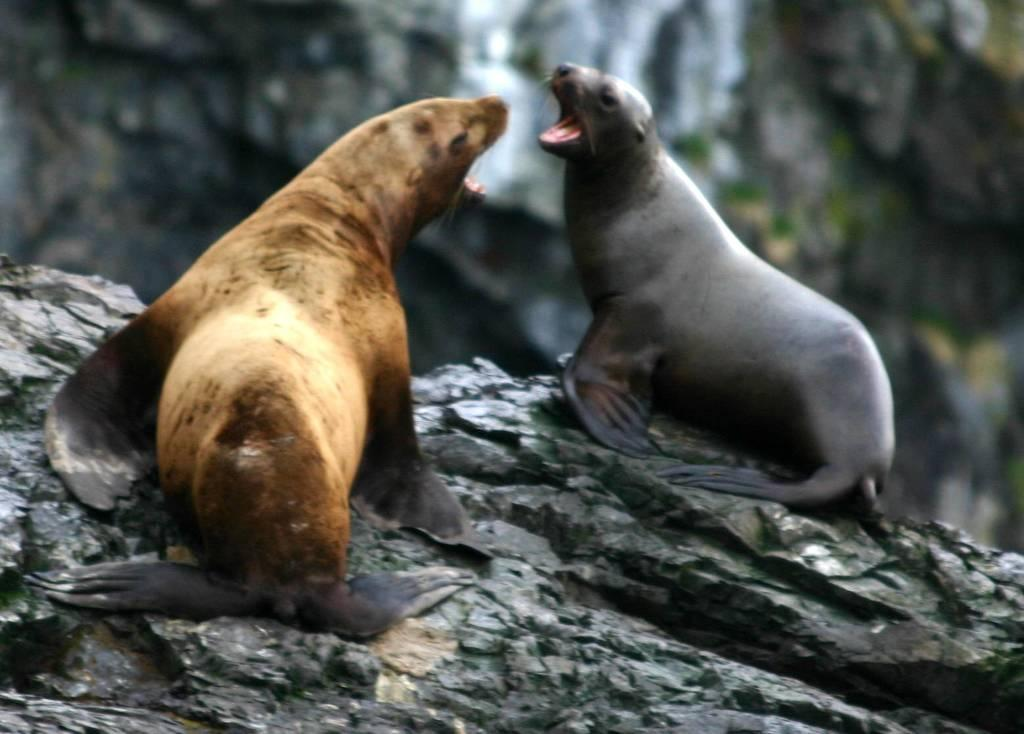What animals are present in the image? There are two sea lions in the image. What is the sea lions' position on the stone? The sea lions are on a stone, and they are facing each other. What action are the sea lions performing? The sea lions are opening their mouths. What can be seen in the background of the image? There is a big rock in the background of the image. What type of butter is being used to sew a skirt in the image? There is no butter or sewing activity present in the image; it features two sea lions on a stone. What color is the thread used to make the skirt in the image? There is no skirt or thread present in the image. 